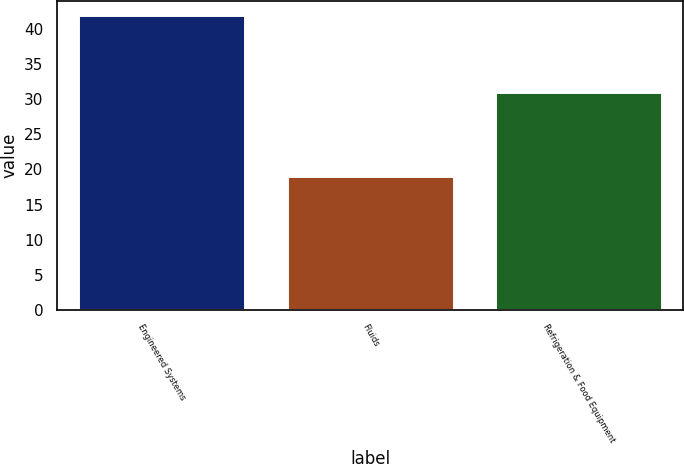Convert chart to OTSL. <chart><loc_0><loc_0><loc_500><loc_500><bar_chart><fcel>Engineered Systems<fcel>Fluids<fcel>Refrigeration & Food Equipment<nl><fcel>42<fcel>19<fcel>31<nl></chart> 